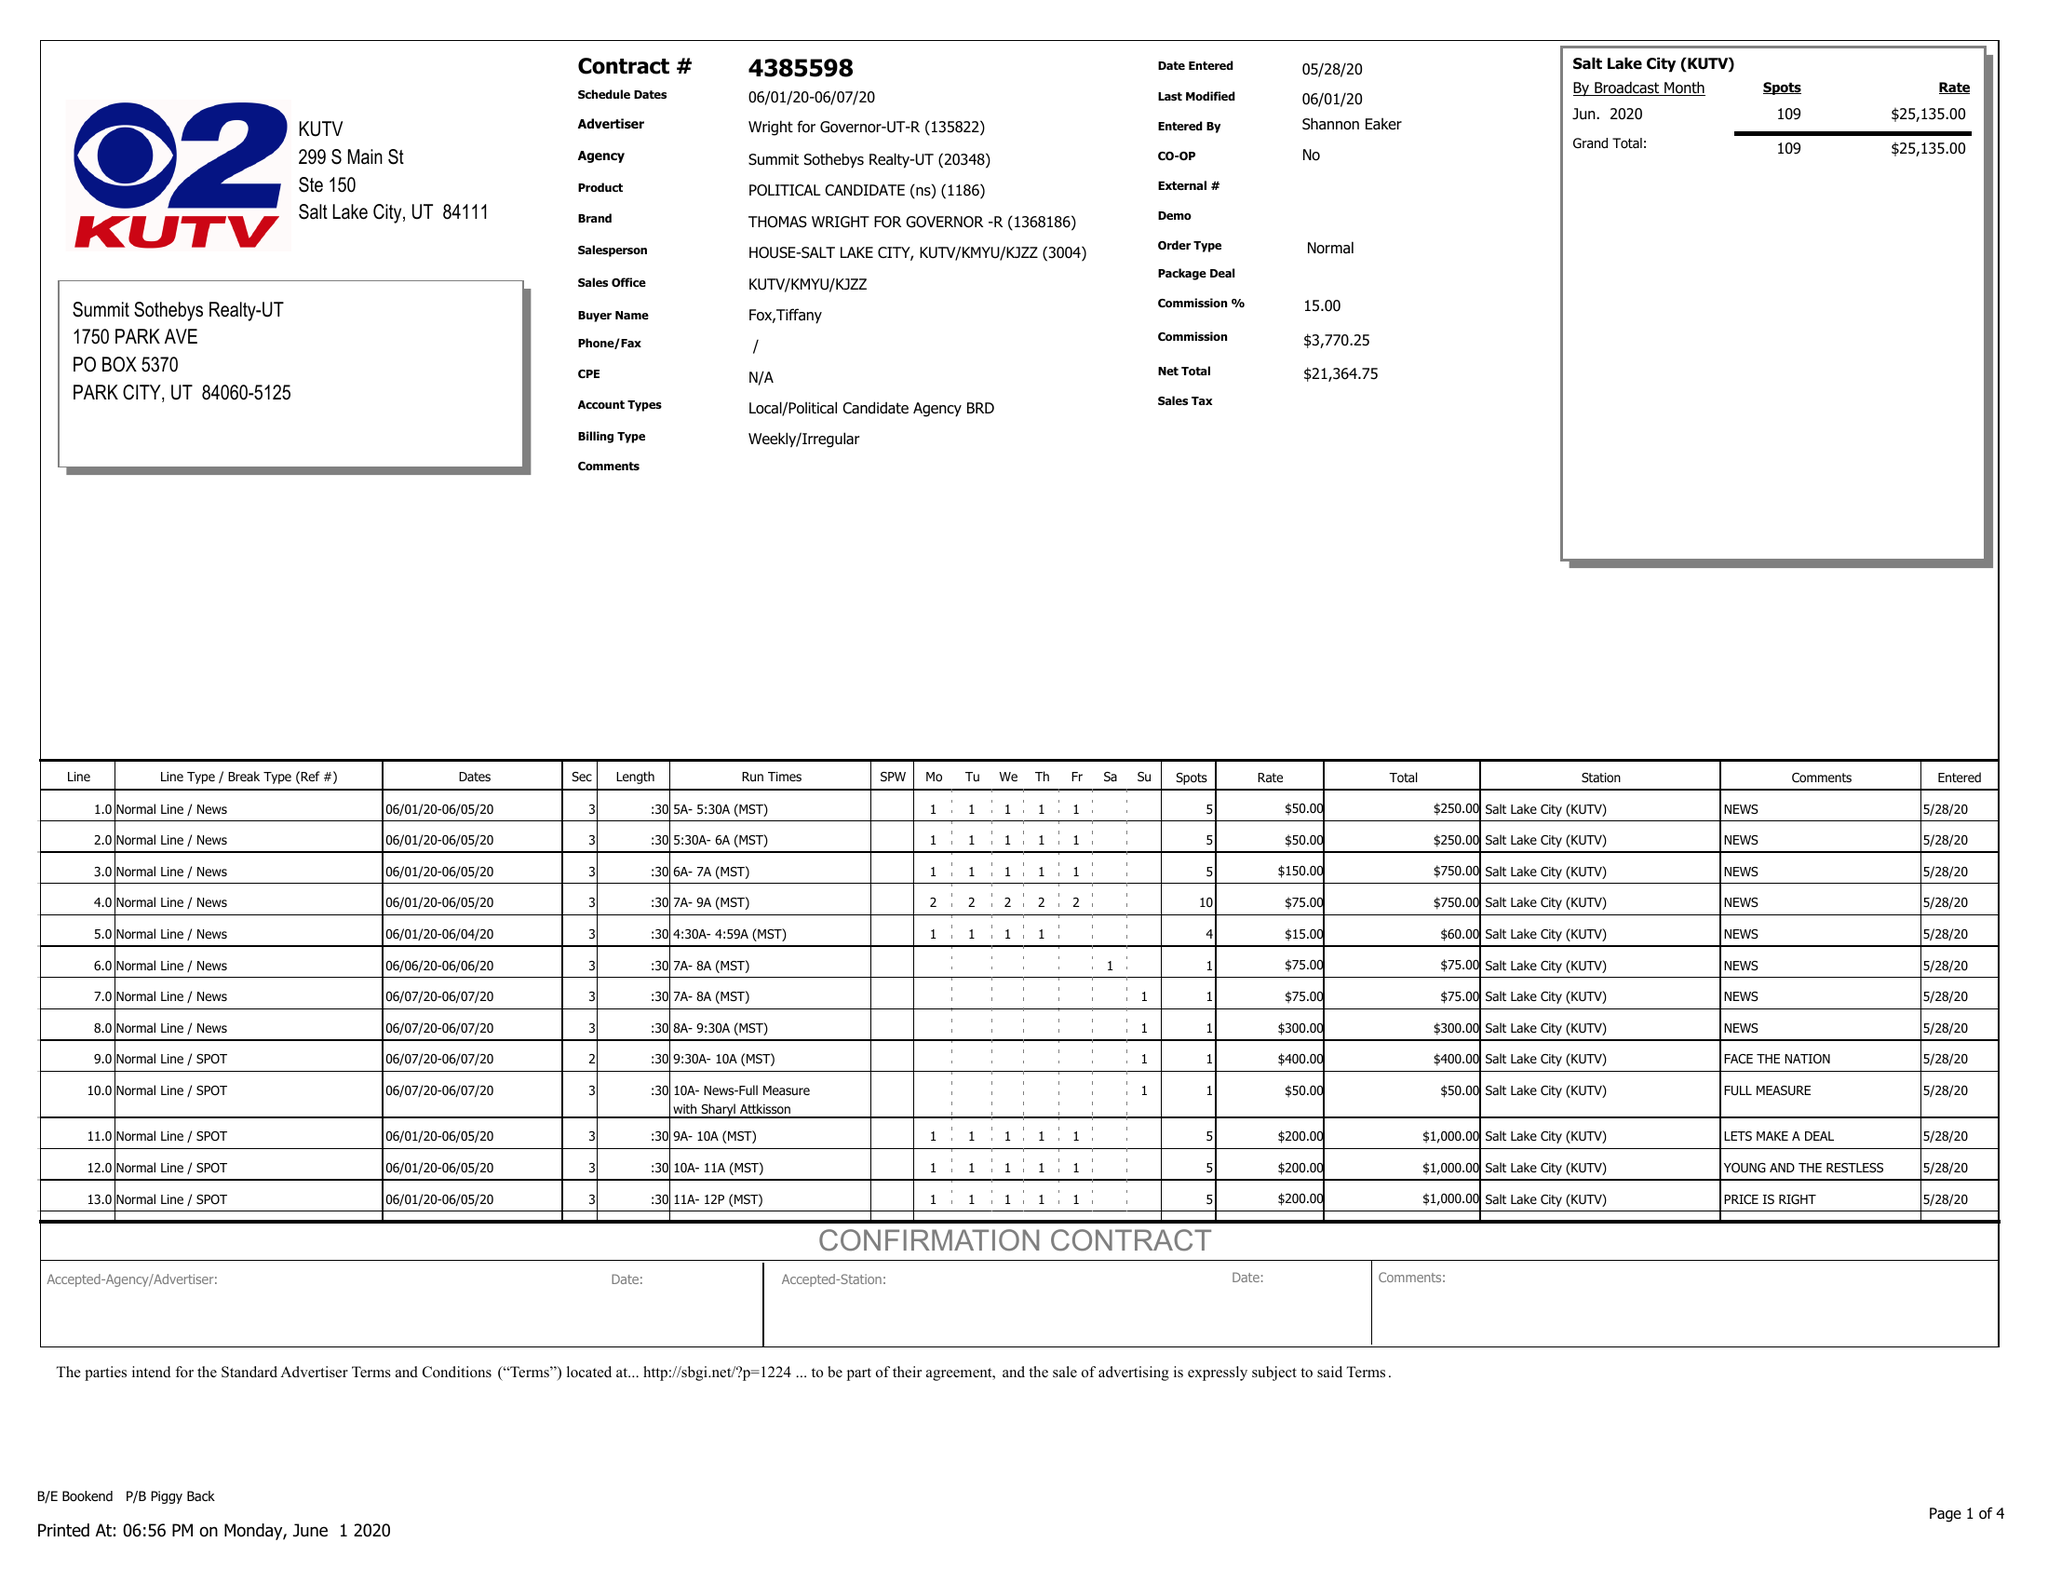What is the value for the contract_num?
Answer the question using a single word or phrase. 4385598 